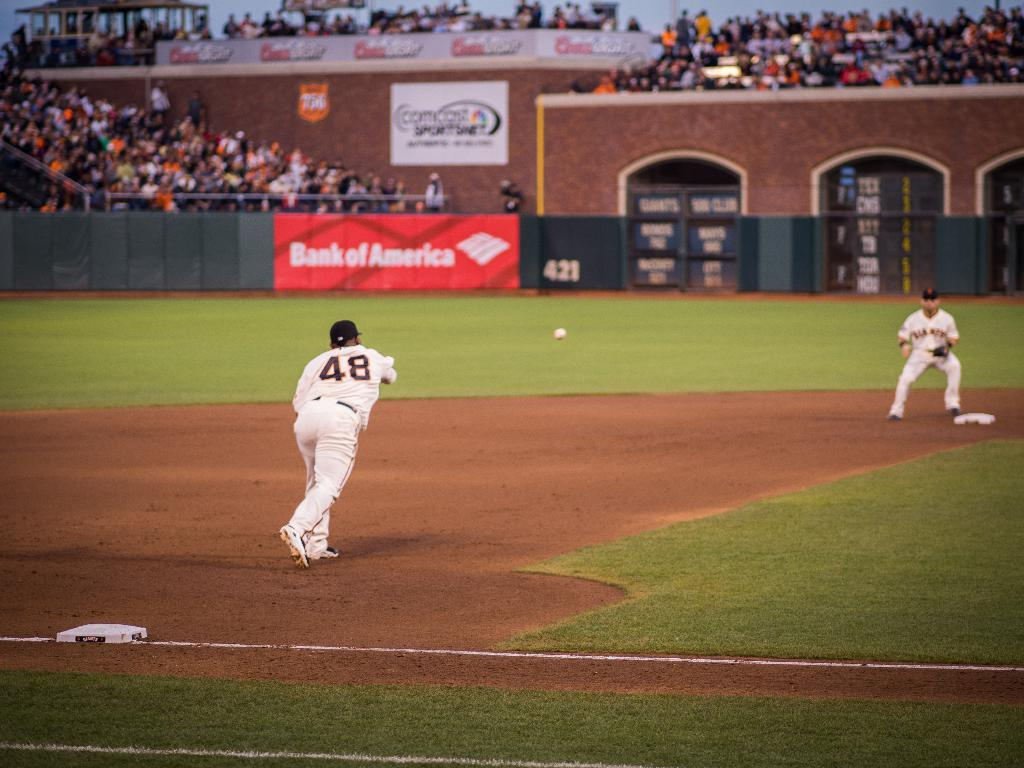Provide a one-sentence caption for the provided image. A baseball pitcher bearing the number 48 throws a ball towards a plate in a stdium bearing Bank of America sponsorship. 